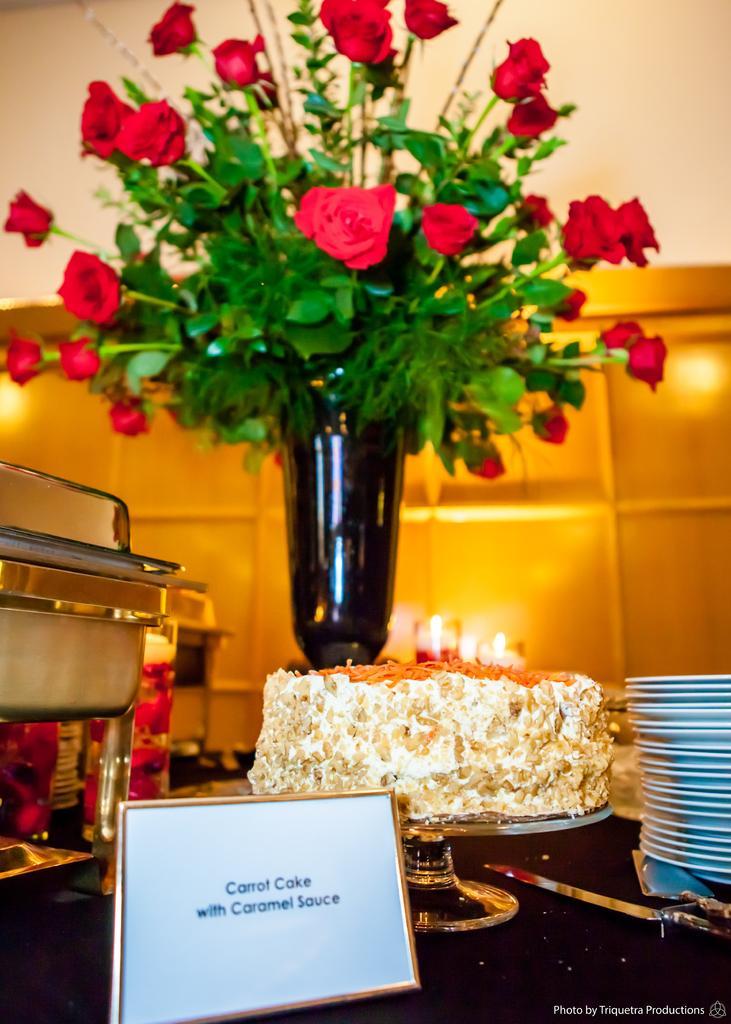In one or two sentences, can you explain what this image depicts? In the foreground of the picture there are plates, name plate, cake, flowers, flower vase, bowl, glasses, knife and various objects on the table. The background is blurred. 